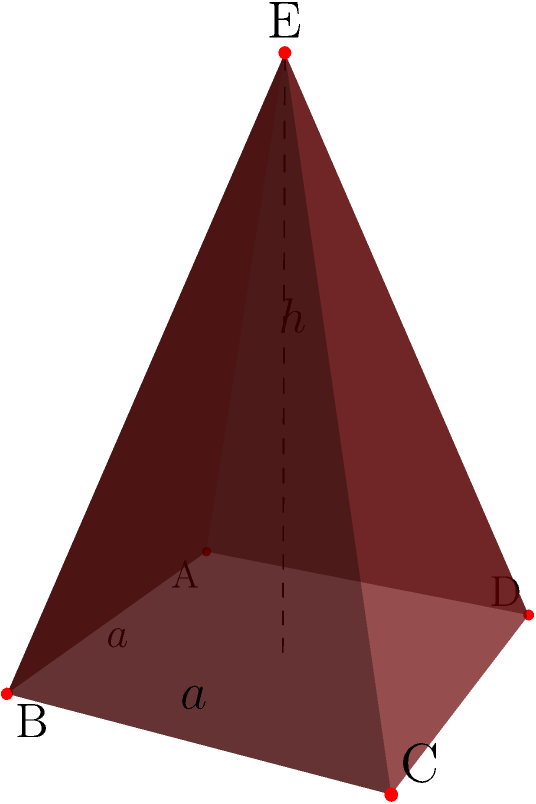As a historian sharing knowledge with your children, you want to explain the volume and stability of ancient Egyptian pyramids. Given a square-based pyramid with a base side length of $a=440$ cubits and a height of $h=280$ cubits, calculate its volume and discuss how its shape contributes to its remarkable stability over millennia. To explain this to your children, let's break it down step-by-step:

1) First, we need to calculate the volume of the pyramid. The formula for the volume of a pyramid is:

   $$V = \frac{1}{3} \times B \times h$$

   Where $B$ is the area of the base and $h$ is the height.

2) The base is a square with side length $a$, so its area is:

   $$B = a^2 = 440^2 = 193,600 \text{ square cubits}$$

3) Now we can plug this into our volume formula:

   $$V = \frac{1}{3} \times 193,600 \times 280 = 18,069,333.33 \text{ cubic cubits}$$

4) As for the stability, the pyramid shape is inherently stable due to several factors:

   a) Wide base: The broad base distributes the weight over a large area, preventing sinking.
   
   b) Center of gravity: The pyramid's center of gravity is very low, making it resistant to toppling.
   
   c) Inward slope: The sloping sides direct the force of gravity towards the center, increasing stability.
   
   d) Interlocking stones: The ancient Egyptians used precisely cut stones that fit tightly together, enhancing structural integrity.

5) The ratio of the base width to height (440:280 or about 11:7) also contributes to stability. A wider base relative to height increases stability.

This combination of volume and shape has allowed pyramids like the Great Pyramid of Giza to stand for over 4,500 years, withstanding earthquakes, wind, and other natural forces.
Answer: Volume: 18,069,333.33 cubic cubits. Stability due to wide base, low center of gravity, inward slope, and interlocking stones. 